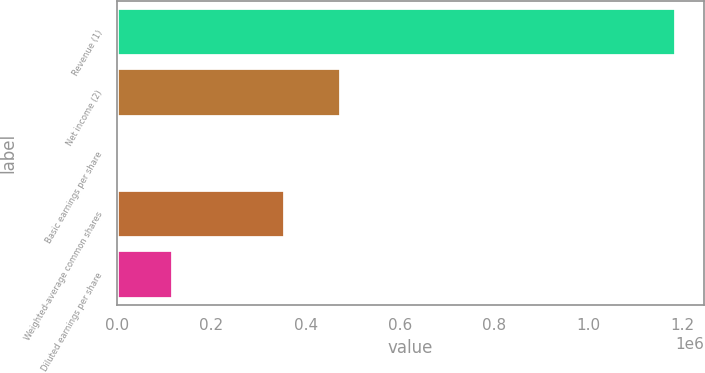Convert chart. <chart><loc_0><loc_0><loc_500><loc_500><bar_chart><fcel>Revenue (1)<fcel>Net income (2)<fcel>Basic earnings per share<fcel>Weighted-average common shares<fcel>Diluted earnings per share<nl><fcel>1.18692e+06<fcel>474767<fcel>1.24<fcel>356076<fcel>118693<nl></chart> 